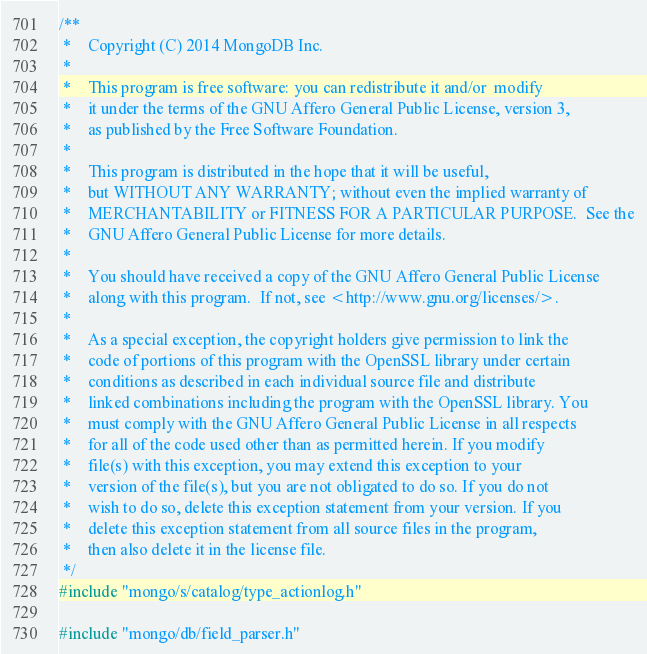<code> <loc_0><loc_0><loc_500><loc_500><_C++_>/**
 *    Copyright (C) 2014 MongoDB Inc.
 *
 *    This program is free software: you can redistribute it and/or  modify
 *    it under the terms of the GNU Affero General Public License, version 3,
 *    as published by the Free Software Foundation.
 *
 *    This program is distributed in the hope that it will be useful,
 *    but WITHOUT ANY WARRANTY; without even the implied warranty of
 *    MERCHANTABILITY or FITNESS FOR A PARTICULAR PURPOSE.  See the
 *    GNU Affero General Public License for more details.
 *
 *    You should have received a copy of the GNU Affero General Public License
 *    along with this program.  If not, see <http://www.gnu.org/licenses/>.
 *
 *    As a special exception, the copyright holders give permission to link the
 *    code of portions of this program with the OpenSSL library under certain
 *    conditions as described in each individual source file and distribute
 *    linked combinations including the program with the OpenSSL library. You
 *    must comply with the GNU Affero General Public License in all respects
 *    for all of the code used other than as permitted herein. If you modify
 *    file(s) with this exception, you may extend this exception to your
 *    version of the file(s), but you are not obligated to do so. If you do not
 *    wish to do so, delete this exception statement from your version. If you
 *    delete this exception statement from all source files in the program,
 *    then also delete it in the license file.
 */
#include "mongo/s/catalog/type_actionlog.h"

#include "mongo/db/field_parser.h"</code> 